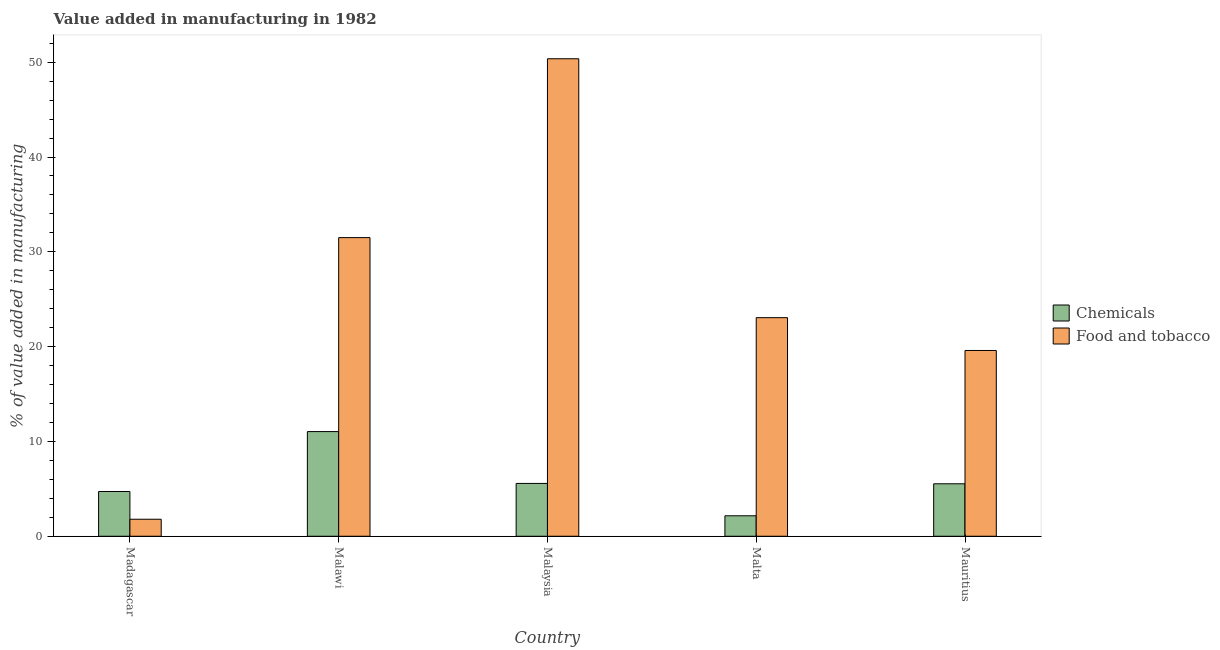Are the number of bars per tick equal to the number of legend labels?
Your answer should be very brief. Yes. How many bars are there on the 5th tick from the right?
Offer a very short reply. 2. What is the label of the 3rd group of bars from the left?
Give a very brief answer. Malaysia. What is the value added by manufacturing food and tobacco in Mauritius?
Offer a very short reply. 19.59. Across all countries, what is the maximum value added by manufacturing food and tobacco?
Give a very brief answer. 50.36. Across all countries, what is the minimum value added by manufacturing food and tobacco?
Your response must be concise. 1.79. In which country was the value added by manufacturing food and tobacco maximum?
Give a very brief answer. Malaysia. In which country was the value added by manufacturing food and tobacco minimum?
Offer a terse response. Madagascar. What is the total value added by  manufacturing chemicals in the graph?
Make the answer very short. 29.02. What is the difference between the value added by  manufacturing chemicals in Malaysia and that in Mauritius?
Ensure brevity in your answer.  0.04. What is the difference between the value added by  manufacturing chemicals in Madagascar and the value added by manufacturing food and tobacco in Malta?
Provide a short and direct response. -18.34. What is the average value added by  manufacturing chemicals per country?
Ensure brevity in your answer.  5.8. What is the difference between the value added by  manufacturing chemicals and value added by manufacturing food and tobacco in Malaysia?
Your answer should be compact. -44.79. What is the ratio of the value added by  manufacturing chemicals in Malawi to that in Malta?
Ensure brevity in your answer.  5.12. Is the value added by  manufacturing chemicals in Madagascar less than that in Mauritius?
Offer a very short reply. Yes. Is the difference between the value added by  manufacturing chemicals in Malaysia and Mauritius greater than the difference between the value added by manufacturing food and tobacco in Malaysia and Mauritius?
Your answer should be compact. No. What is the difference between the highest and the second highest value added by manufacturing food and tobacco?
Provide a succinct answer. 18.87. What is the difference between the highest and the lowest value added by manufacturing food and tobacco?
Offer a terse response. 48.57. In how many countries, is the value added by  manufacturing chemicals greater than the average value added by  manufacturing chemicals taken over all countries?
Your response must be concise. 1. Is the sum of the value added by  manufacturing chemicals in Madagascar and Malawi greater than the maximum value added by manufacturing food and tobacco across all countries?
Offer a terse response. No. What does the 1st bar from the left in Malaysia represents?
Provide a succinct answer. Chemicals. What does the 2nd bar from the right in Mauritius represents?
Keep it short and to the point. Chemicals. How many bars are there?
Provide a short and direct response. 10. What is the difference between two consecutive major ticks on the Y-axis?
Make the answer very short. 10. Are the values on the major ticks of Y-axis written in scientific E-notation?
Provide a short and direct response. No. Does the graph contain any zero values?
Make the answer very short. No. How are the legend labels stacked?
Give a very brief answer. Vertical. What is the title of the graph?
Offer a terse response. Value added in manufacturing in 1982. What is the label or title of the Y-axis?
Keep it short and to the point. % of value added in manufacturing. What is the % of value added in manufacturing in Chemicals in Madagascar?
Your answer should be compact. 4.72. What is the % of value added in manufacturing of Food and tobacco in Madagascar?
Give a very brief answer. 1.79. What is the % of value added in manufacturing in Chemicals in Malawi?
Keep it short and to the point. 11.04. What is the % of value added in manufacturing of Food and tobacco in Malawi?
Give a very brief answer. 31.5. What is the % of value added in manufacturing in Chemicals in Malaysia?
Give a very brief answer. 5.57. What is the % of value added in manufacturing in Food and tobacco in Malaysia?
Offer a very short reply. 50.36. What is the % of value added in manufacturing of Chemicals in Malta?
Keep it short and to the point. 2.16. What is the % of value added in manufacturing of Food and tobacco in Malta?
Give a very brief answer. 23.06. What is the % of value added in manufacturing of Chemicals in Mauritius?
Your answer should be very brief. 5.53. What is the % of value added in manufacturing of Food and tobacco in Mauritius?
Keep it short and to the point. 19.59. Across all countries, what is the maximum % of value added in manufacturing in Chemicals?
Offer a terse response. 11.04. Across all countries, what is the maximum % of value added in manufacturing in Food and tobacco?
Ensure brevity in your answer.  50.36. Across all countries, what is the minimum % of value added in manufacturing in Chemicals?
Give a very brief answer. 2.16. Across all countries, what is the minimum % of value added in manufacturing in Food and tobacco?
Offer a very short reply. 1.79. What is the total % of value added in manufacturing of Chemicals in the graph?
Provide a short and direct response. 29.02. What is the total % of value added in manufacturing of Food and tobacco in the graph?
Offer a terse response. 126.3. What is the difference between the % of value added in manufacturing in Chemicals in Madagascar and that in Malawi?
Your response must be concise. -6.32. What is the difference between the % of value added in manufacturing of Food and tobacco in Madagascar and that in Malawi?
Your answer should be very brief. -29.7. What is the difference between the % of value added in manufacturing in Chemicals in Madagascar and that in Malaysia?
Give a very brief answer. -0.85. What is the difference between the % of value added in manufacturing of Food and tobacco in Madagascar and that in Malaysia?
Give a very brief answer. -48.57. What is the difference between the % of value added in manufacturing of Chemicals in Madagascar and that in Malta?
Make the answer very short. 2.56. What is the difference between the % of value added in manufacturing of Food and tobacco in Madagascar and that in Malta?
Your response must be concise. -21.26. What is the difference between the % of value added in manufacturing of Chemicals in Madagascar and that in Mauritius?
Your answer should be compact. -0.81. What is the difference between the % of value added in manufacturing of Food and tobacco in Madagascar and that in Mauritius?
Your answer should be compact. -17.8. What is the difference between the % of value added in manufacturing in Chemicals in Malawi and that in Malaysia?
Offer a very short reply. 5.47. What is the difference between the % of value added in manufacturing in Food and tobacco in Malawi and that in Malaysia?
Make the answer very short. -18.87. What is the difference between the % of value added in manufacturing of Chemicals in Malawi and that in Malta?
Your answer should be compact. 8.88. What is the difference between the % of value added in manufacturing of Food and tobacco in Malawi and that in Malta?
Offer a very short reply. 8.44. What is the difference between the % of value added in manufacturing of Chemicals in Malawi and that in Mauritius?
Make the answer very short. 5.51. What is the difference between the % of value added in manufacturing of Food and tobacco in Malawi and that in Mauritius?
Make the answer very short. 11.9. What is the difference between the % of value added in manufacturing of Chemicals in Malaysia and that in Malta?
Offer a terse response. 3.41. What is the difference between the % of value added in manufacturing of Food and tobacco in Malaysia and that in Malta?
Keep it short and to the point. 27.31. What is the difference between the % of value added in manufacturing in Chemicals in Malaysia and that in Mauritius?
Provide a succinct answer. 0.04. What is the difference between the % of value added in manufacturing of Food and tobacco in Malaysia and that in Mauritius?
Provide a succinct answer. 30.77. What is the difference between the % of value added in manufacturing in Chemicals in Malta and that in Mauritius?
Provide a succinct answer. -3.37. What is the difference between the % of value added in manufacturing in Food and tobacco in Malta and that in Mauritius?
Your response must be concise. 3.46. What is the difference between the % of value added in manufacturing in Chemicals in Madagascar and the % of value added in manufacturing in Food and tobacco in Malawi?
Provide a short and direct response. -26.78. What is the difference between the % of value added in manufacturing of Chemicals in Madagascar and the % of value added in manufacturing of Food and tobacco in Malaysia?
Offer a very short reply. -45.64. What is the difference between the % of value added in manufacturing of Chemicals in Madagascar and the % of value added in manufacturing of Food and tobacco in Malta?
Provide a short and direct response. -18.34. What is the difference between the % of value added in manufacturing of Chemicals in Madagascar and the % of value added in manufacturing of Food and tobacco in Mauritius?
Give a very brief answer. -14.87. What is the difference between the % of value added in manufacturing in Chemicals in Malawi and the % of value added in manufacturing in Food and tobacco in Malaysia?
Your response must be concise. -39.32. What is the difference between the % of value added in manufacturing in Chemicals in Malawi and the % of value added in manufacturing in Food and tobacco in Malta?
Your answer should be very brief. -12.02. What is the difference between the % of value added in manufacturing of Chemicals in Malawi and the % of value added in manufacturing of Food and tobacco in Mauritius?
Ensure brevity in your answer.  -8.55. What is the difference between the % of value added in manufacturing of Chemicals in Malaysia and the % of value added in manufacturing of Food and tobacco in Malta?
Provide a succinct answer. -17.48. What is the difference between the % of value added in manufacturing of Chemicals in Malaysia and the % of value added in manufacturing of Food and tobacco in Mauritius?
Give a very brief answer. -14.02. What is the difference between the % of value added in manufacturing in Chemicals in Malta and the % of value added in manufacturing in Food and tobacco in Mauritius?
Keep it short and to the point. -17.44. What is the average % of value added in manufacturing in Chemicals per country?
Your answer should be compact. 5.8. What is the average % of value added in manufacturing in Food and tobacco per country?
Ensure brevity in your answer.  25.26. What is the difference between the % of value added in manufacturing in Chemicals and % of value added in manufacturing in Food and tobacco in Madagascar?
Your response must be concise. 2.93. What is the difference between the % of value added in manufacturing of Chemicals and % of value added in manufacturing of Food and tobacco in Malawi?
Offer a very short reply. -20.46. What is the difference between the % of value added in manufacturing in Chemicals and % of value added in manufacturing in Food and tobacco in Malaysia?
Your answer should be very brief. -44.79. What is the difference between the % of value added in manufacturing in Chemicals and % of value added in manufacturing in Food and tobacco in Malta?
Make the answer very short. -20.9. What is the difference between the % of value added in manufacturing in Chemicals and % of value added in manufacturing in Food and tobacco in Mauritius?
Provide a short and direct response. -14.06. What is the ratio of the % of value added in manufacturing of Chemicals in Madagascar to that in Malawi?
Make the answer very short. 0.43. What is the ratio of the % of value added in manufacturing in Food and tobacco in Madagascar to that in Malawi?
Ensure brevity in your answer.  0.06. What is the ratio of the % of value added in manufacturing in Chemicals in Madagascar to that in Malaysia?
Your response must be concise. 0.85. What is the ratio of the % of value added in manufacturing of Food and tobacco in Madagascar to that in Malaysia?
Keep it short and to the point. 0.04. What is the ratio of the % of value added in manufacturing of Chemicals in Madagascar to that in Malta?
Offer a very short reply. 2.19. What is the ratio of the % of value added in manufacturing of Food and tobacco in Madagascar to that in Malta?
Your response must be concise. 0.08. What is the ratio of the % of value added in manufacturing in Chemicals in Madagascar to that in Mauritius?
Offer a terse response. 0.85. What is the ratio of the % of value added in manufacturing of Food and tobacco in Madagascar to that in Mauritius?
Ensure brevity in your answer.  0.09. What is the ratio of the % of value added in manufacturing in Chemicals in Malawi to that in Malaysia?
Your response must be concise. 1.98. What is the ratio of the % of value added in manufacturing in Food and tobacco in Malawi to that in Malaysia?
Provide a succinct answer. 0.63. What is the ratio of the % of value added in manufacturing of Chemicals in Malawi to that in Malta?
Your response must be concise. 5.12. What is the ratio of the % of value added in manufacturing of Food and tobacco in Malawi to that in Malta?
Your answer should be compact. 1.37. What is the ratio of the % of value added in manufacturing of Chemicals in Malawi to that in Mauritius?
Give a very brief answer. 2. What is the ratio of the % of value added in manufacturing in Food and tobacco in Malawi to that in Mauritius?
Offer a terse response. 1.61. What is the ratio of the % of value added in manufacturing of Chemicals in Malaysia to that in Malta?
Offer a very short reply. 2.58. What is the ratio of the % of value added in manufacturing of Food and tobacco in Malaysia to that in Malta?
Make the answer very short. 2.18. What is the ratio of the % of value added in manufacturing in Food and tobacco in Malaysia to that in Mauritius?
Keep it short and to the point. 2.57. What is the ratio of the % of value added in manufacturing in Chemicals in Malta to that in Mauritius?
Keep it short and to the point. 0.39. What is the ratio of the % of value added in manufacturing in Food and tobacco in Malta to that in Mauritius?
Make the answer very short. 1.18. What is the difference between the highest and the second highest % of value added in manufacturing in Chemicals?
Provide a succinct answer. 5.47. What is the difference between the highest and the second highest % of value added in manufacturing in Food and tobacco?
Give a very brief answer. 18.87. What is the difference between the highest and the lowest % of value added in manufacturing in Chemicals?
Offer a terse response. 8.88. What is the difference between the highest and the lowest % of value added in manufacturing of Food and tobacco?
Offer a very short reply. 48.57. 